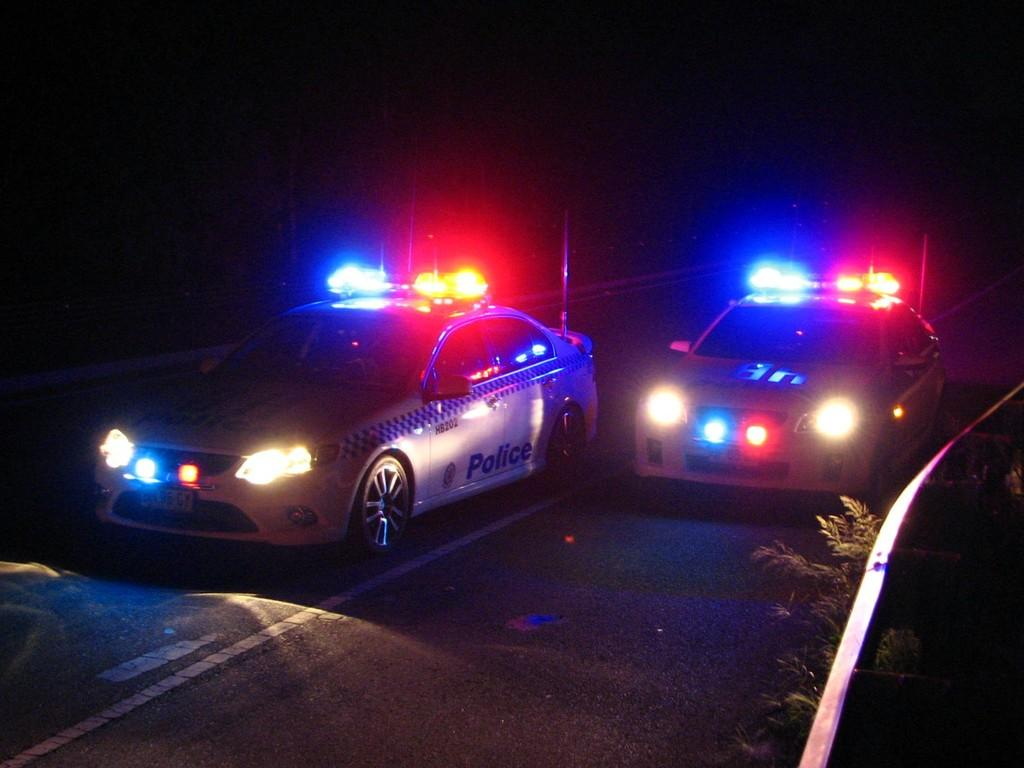What can be seen in the center of the image? There are two cars in the center of the image. What is located at the bottom of the image? There is a road at the bottom of the image. What can be seen illuminated in the image? There are lights visible in the image. What type of vegetation is present in the image? There are plants in the image. What type of wilderness can be seen in the background of the image? There is no wilderness present in the image; it features a road, cars, lights, and plants. What day of the week is depicted in the image? The day of the week cannot be determined from the image, as it does not contain any information about the date or time. 